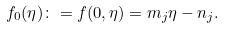Convert formula to latex. <formula><loc_0><loc_0><loc_500><loc_500>f _ { 0 } ( \eta ) \colon = f ( 0 , \eta ) = m _ { j } \eta - n _ { j } .</formula> 